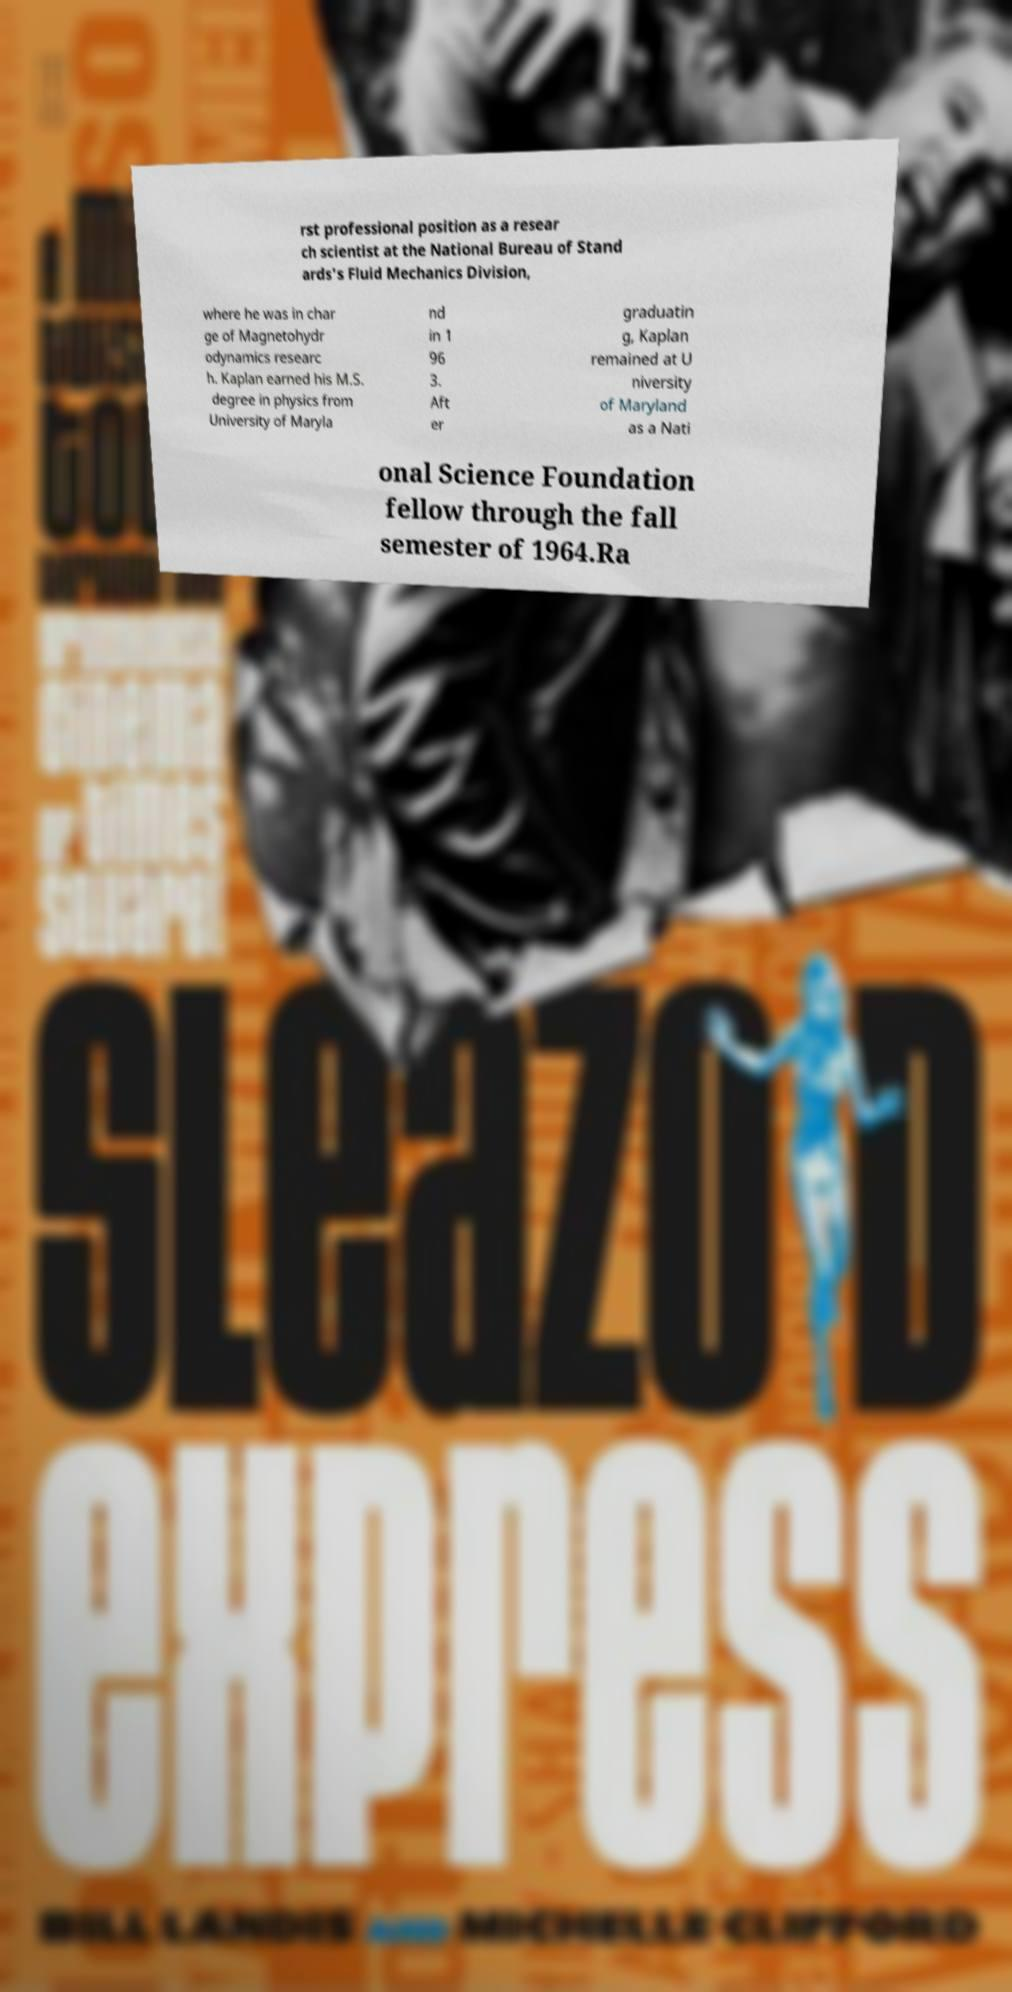There's text embedded in this image that I need extracted. Can you transcribe it verbatim? rst professional position as a resear ch scientist at the National Bureau of Stand ards's Fluid Mechanics Division, where he was in char ge of Magnetohydr odynamics researc h. Kaplan earned his M.S. degree in physics from University of Maryla nd in 1 96 3. Aft er graduatin g, Kaplan remained at U niversity of Maryland as a Nati onal Science Foundation fellow through the fall semester of 1964.Ra 